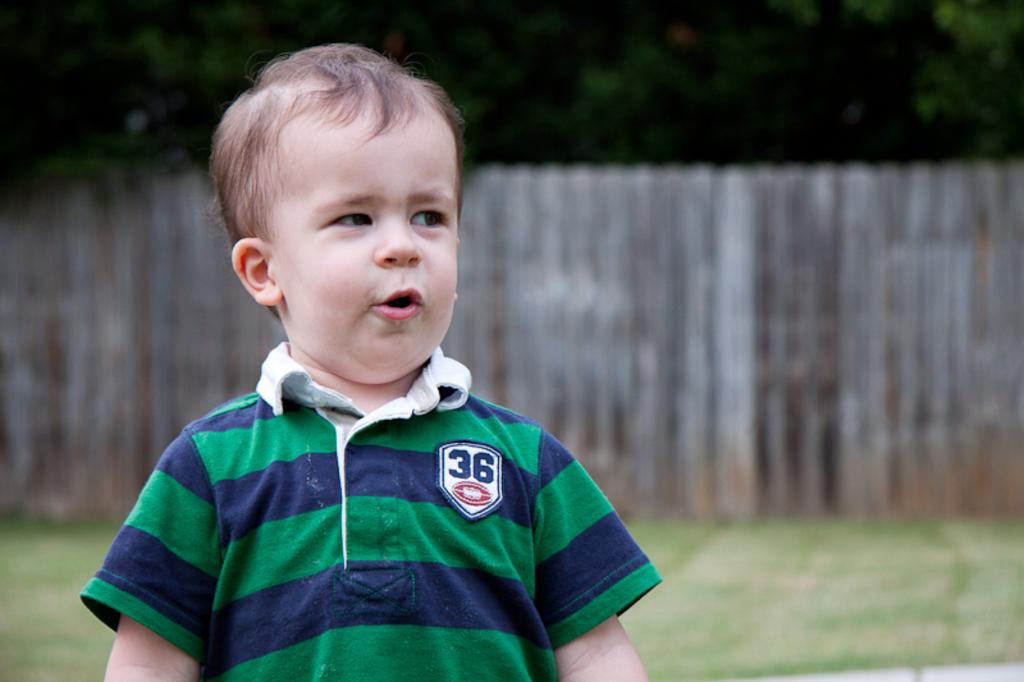What number is on the boys shirt?
Keep it short and to the point. 36. 